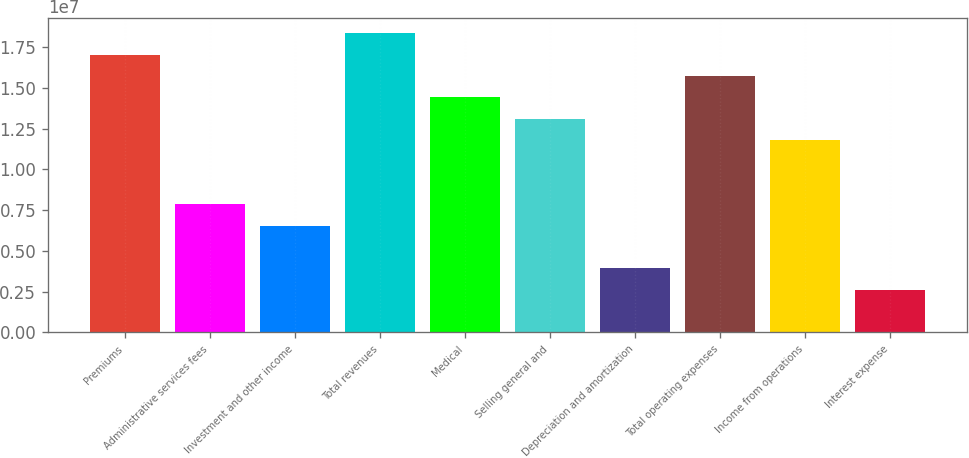Convert chart. <chart><loc_0><loc_0><loc_500><loc_500><bar_chart><fcel>Premiums<fcel>Administrative services fees<fcel>Investment and other income<fcel>Total revenues<fcel>Medical<fcel>Selling general and<fcel>Depreciation and amortization<fcel>Total operating expenses<fcel>Income from operations<fcel>Interest expense<nl><fcel>1.70356e+07<fcel>7.8626e+06<fcel>6.55216e+06<fcel>1.83461e+07<fcel>1.44148e+07<fcel>1.31043e+07<fcel>3.9313e+06<fcel>1.57252e+07<fcel>1.17939e+07<fcel>2.62087e+06<nl></chart> 